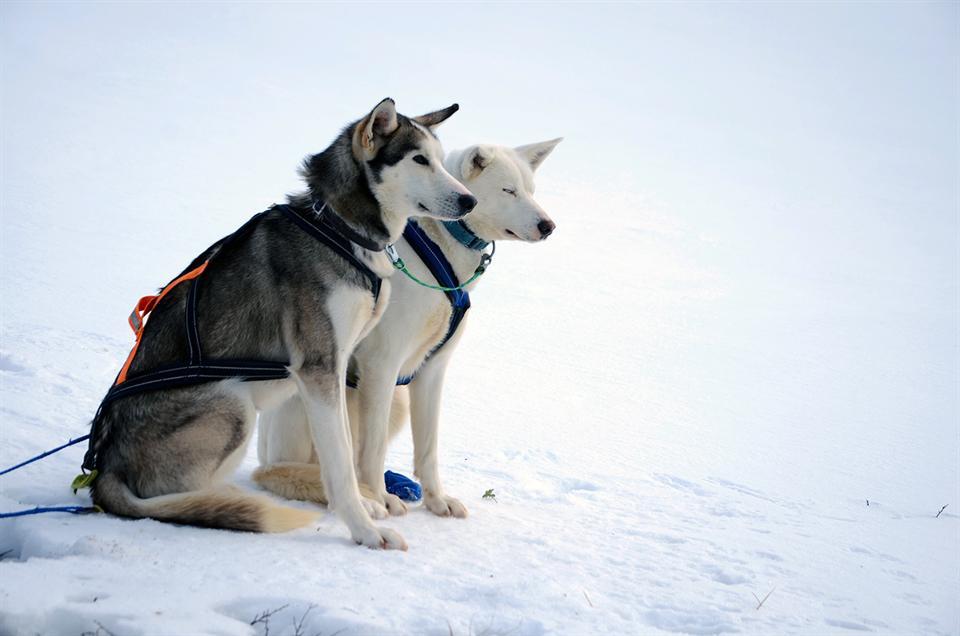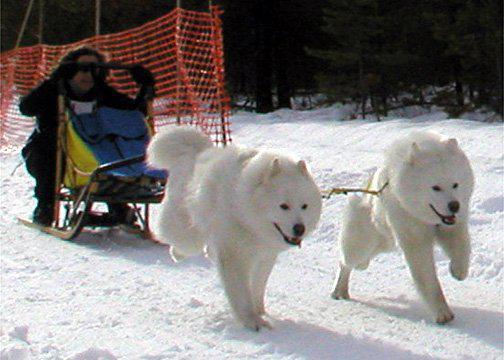The first image is the image on the left, the second image is the image on the right. Evaluate the accuracy of this statement regarding the images: "In one photo dogs are running, and in the other, they are still.". Is it true? Answer yes or no. Yes. The first image is the image on the left, the second image is the image on the right. Evaluate the accuracy of this statement regarding the images: "The person in the image on the left is wearing a red jacket.". Is it true? Answer yes or no. No. 